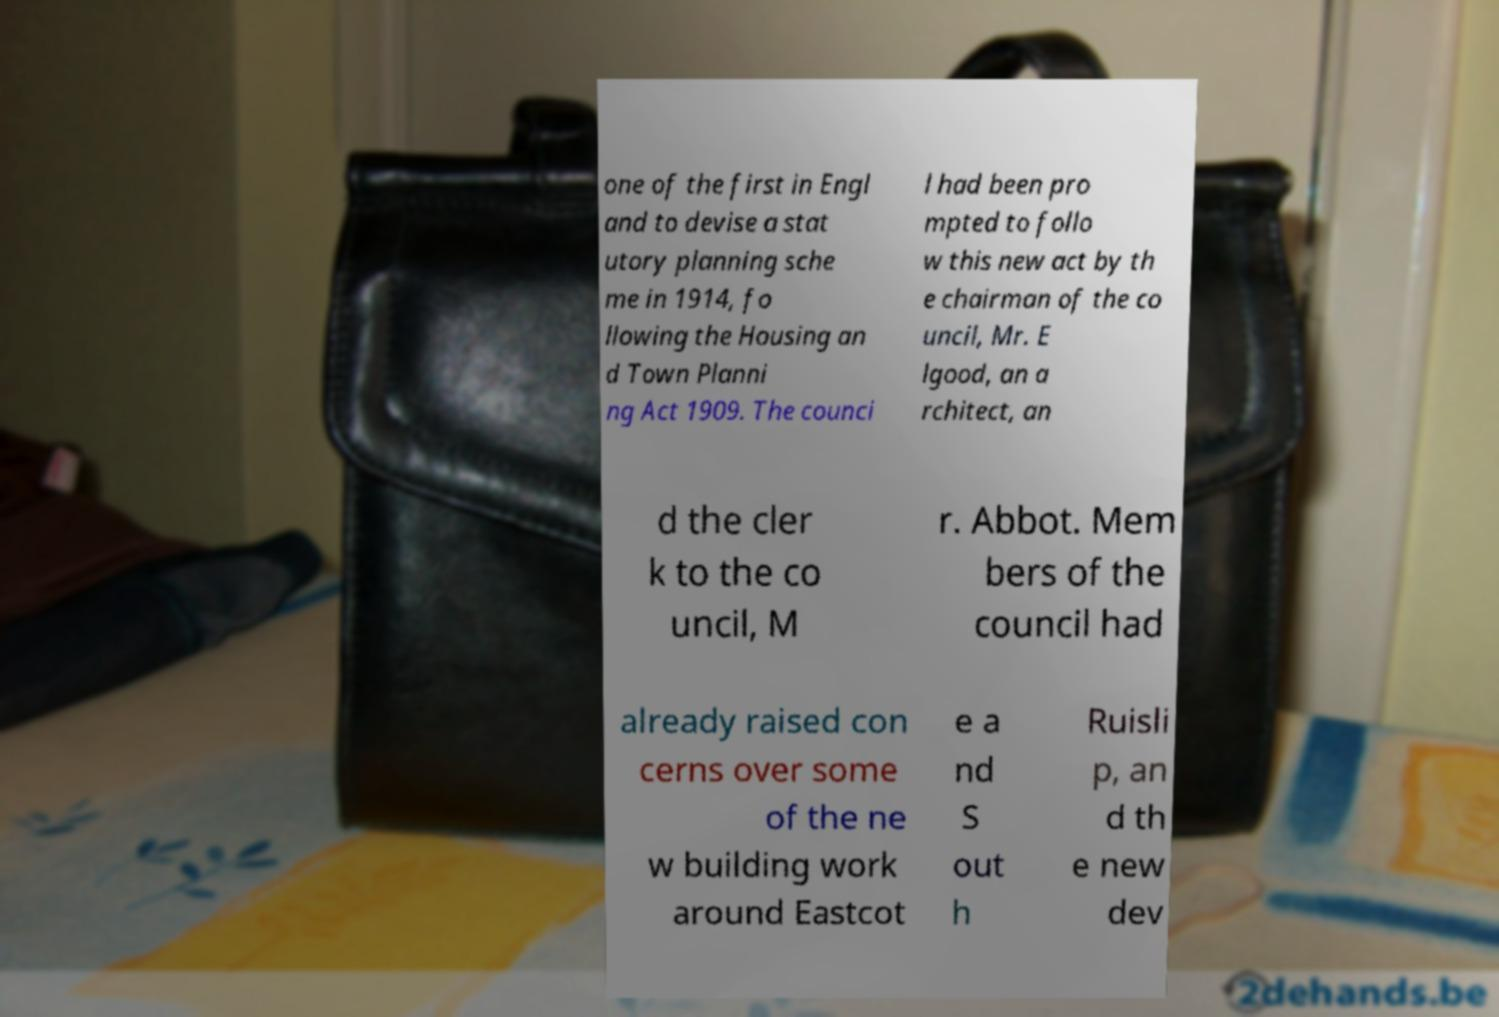What messages or text are displayed in this image? I need them in a readable, typed format. one of the first in Engl and to devise a stat utory planning sche me in 1914, fo llowing the Housing an d Town Planni ng Act 1909. The counci l had been pro mpted to follo w this new act by th e chairman of the co uncil, Mr. E lgood, an a rchitect, an d the cler k to the co uncil, M r. Abbot. Mem bers of the council had already raised con cerns over some of the ne w building work around Eastcot e a nd S out h Ruisli p, an d th e new dev 